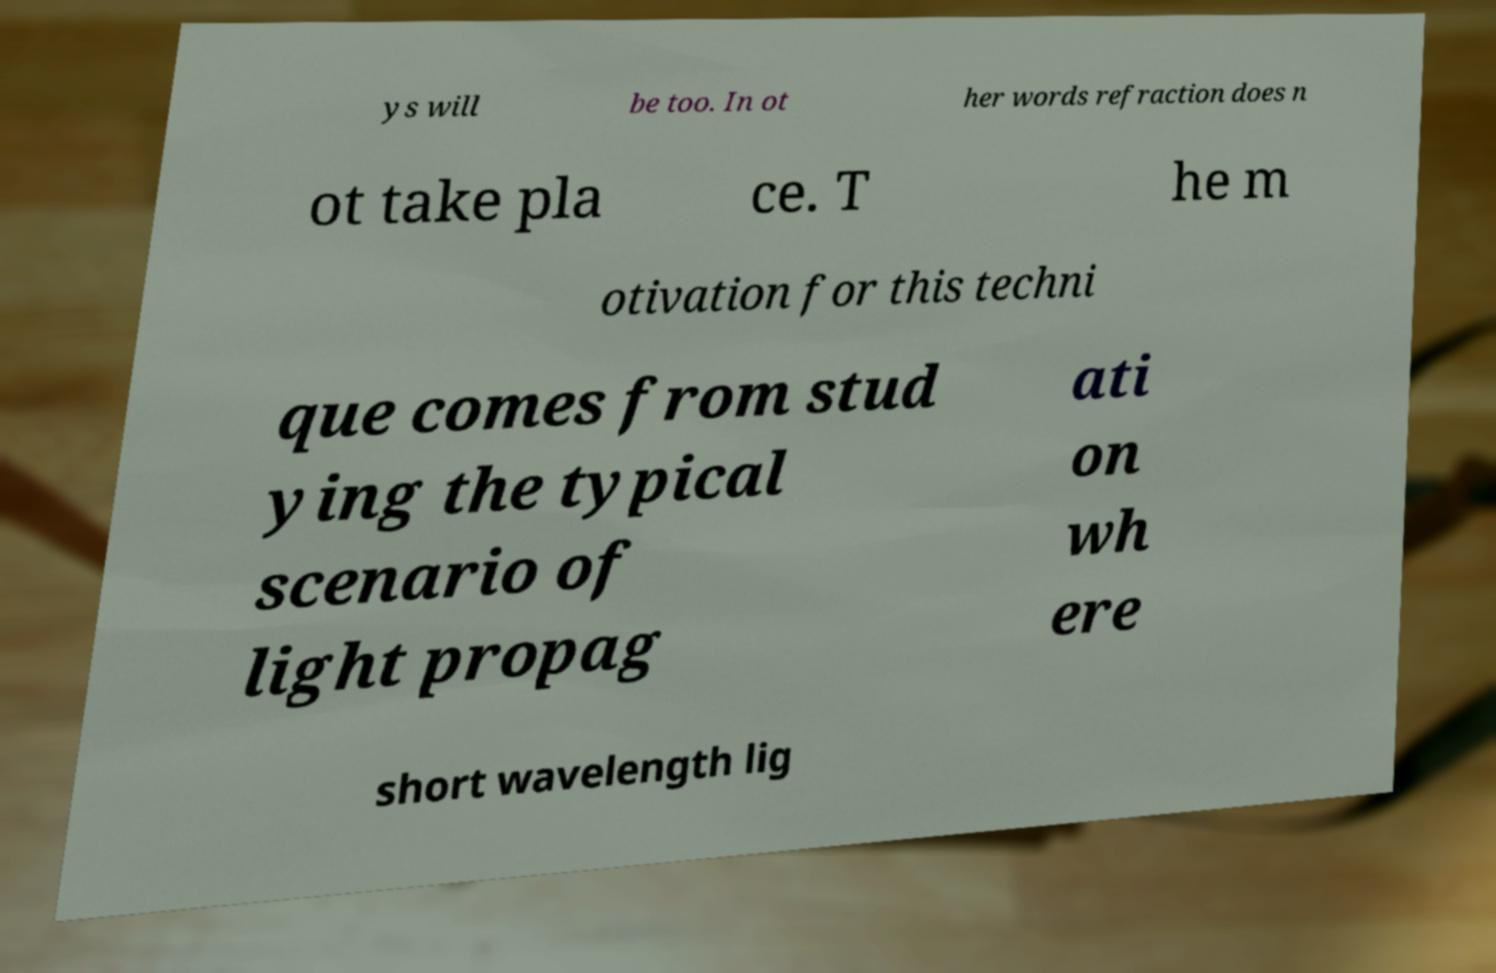What messages or text are displayed in this image? I need them in a readable, typed format. ys will be too. In ot her words refraction does n ot take pla ce. T he m otivation for this techni que comes from stud ying the typical scenario of light propag ati on wh ere short wavelength lig 